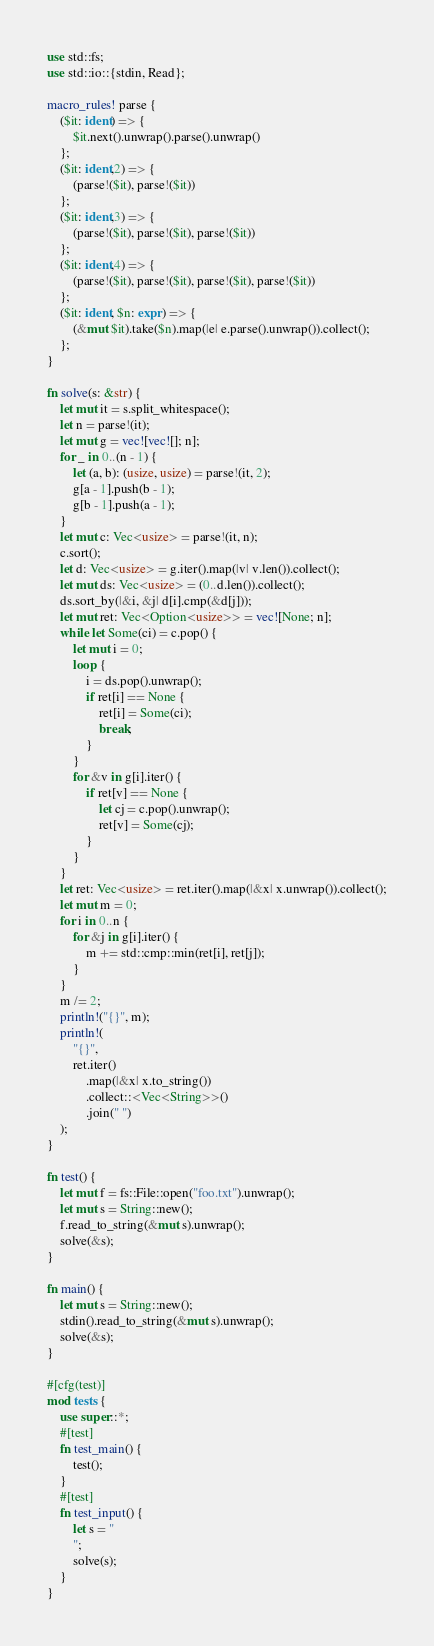<code> <loc_0><loc_0><loc_500><loc_500><_Rust_>use std::fs;
use std::io::{stdin, Read};

macro_rules! parse {
    ($it: ident) => {
        $it.next().unwrap().parse().unwrap()
    };
    ($it: ident,2) => {
        (parse!($it), parse!($it))
    };
    ($it: ident,3) => {
        (parse!($it), parse!($it), parse!($it))
    };
    ($it: ident,4) => {
        (parse!($it), parse!($it), parse!($it), parse!($it))
    };
    ($it: ident, $n: expr) => {
        (&mut $it).take($n).map(|e| e.parse().unwrap()).collect();
    };
}

fn solve(s: &str) {
    let mut it = s.split_whitespace();
    let n = parse!(it);
    let mut g = vec![vec![]; n];
    for _ in 0..(n - 1) {
        let (a, b): (usize, usize) = parse!(it, 2);
        g[a - 1].push(b - 1);
        g[b - 1].push(a - 1);
    }
    let mut c: Vec<usize> = parse!(it, n);
    c.sort();
    let d: Vec<usize> = g.iter().map(|v| v.len()).collect();
    let mut ds: Vec<usize> = (0..d.len()).collect();
    ds.sort_by(|&i, &j| d[i].cmp(&d[j]));
    let mut ret: Vec<Option<usize>> = vec![None; n];
    while let Some(ci) = c.pop() {
        let mut i = 0;
        loop {
            i = ds.pop().unwrap();
            if ret[i] == None {
                ret[i] = Some(ci);
                break;
            }
        }
        for &v in g[i].iter() {
            if ret[v] == None {
                let cj = c.pop().unwrap();
                ret[v] = Some(cj);
            }
        }
    }
    let ret: Vec<usize> = ret.iter().map(|&x| x.unwrap()).collect();
    let mut m = 0;
    for i in 0..n {
        for &j in g[i].iter() {
            m += std::cmp::min(ret[i], ret[j]);
        }
    }
    m /= 2;
    println!("{}", m);
    println!(
        "{}",
        ret.iter()
            .map(|&x| x.to_string())
            .collect::<Vec<String>>()
            .join(" ")
    );
}

fn test() {
    let mut f = fs::File::open("foo.txt").unwrap();
    let mut s = String::new();
    f.read_to_string(&mut s).unwrap();
    solve(&s);
}

fn main() {
    let mut s = String::new();
    stdin().read_to_string(&mut s).unwrap();
    solve(&s);
}

#[cfg(test)]
mod tests {
    use super::*;
    #[test]
    fn test_main() {
        test();
    }
    #[test]
    fn test_input() {
        let s = "
        ";
        solve(s);
    }
}
</code> 